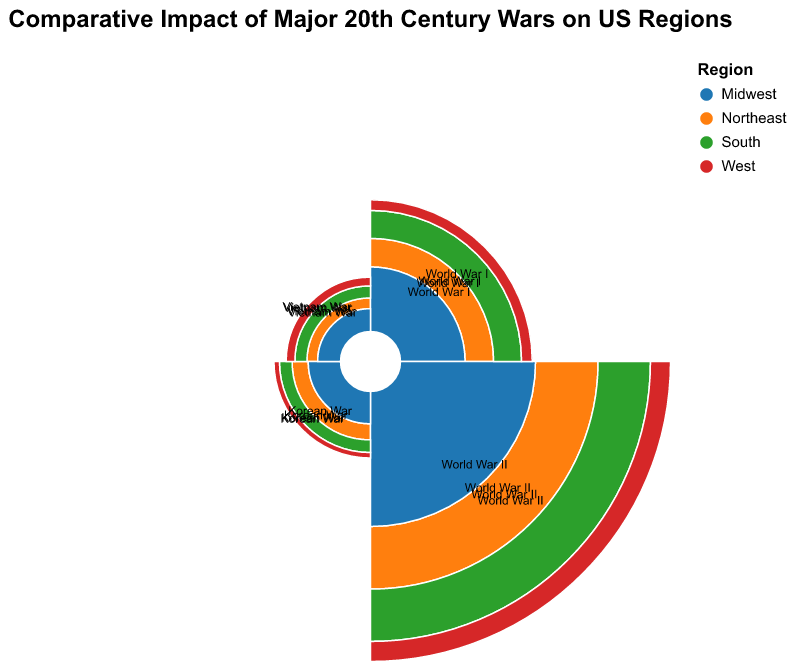what is the economic impact of World War II on the Northeast region? Look for the data point in the polar chart where the "Region" is "Northeast" and the "War" is "World War II". The tooltip information will show the economic impact which is 175,000.
Answer: 175,000 How many regions had more than 50,000 casualties in World War I? Identify the arcs relating to World War I and check the "Casualties" field. Count the regions with casualties exceeding 50,000. The Northeast and South had more than 50,000 casualties.
Answer: 2 Which region experienced the least economic impact from the Vietnam War? Check the economic impact in the text labels or tooltips for the Vietnam War arcs. The Vietnam War's economic impact is lowest in the "Northeast" region (5,000).
Answer: Northeast Is the economic impact of the Korean War higher in the Midwest or the West? Compare the economic impact data for the Korean War between the two regions. Midwest has an economic impact of 9,000, while the West has 4,500. Hence, the Midwest has a higher economic impact.
Answer: Midwest What were the total casualties in the South across all four wars? Sum the casualties for all four wars for the South region: 69,000 (WWI) + 270,000 (WWII) + 16,000 (Korean War) + 11,000 (Vietnam War). This sums up to 366,000.
Answer: 366,000 Which war caused the most casualties in the West? Identify the arc with the largest radius for the West region. World War II caused the most casualties in the West (120,000).
Answer: World War II What is the ratio of World War I to World War II casualties in the Midwest? Divide the World War I casualties by the World War II casualties for the Midwest (48,000/210,000). This ratio simplifies to approximately 0.2286.
Answer: 0.2286 What percentage of the total economic impact of World War I across all regions does the Northeast constitute? Sum the economic impact of World War I across all regions (35,000 + 32,000 + 28,000 + 15,000 = 110,000). Then, divide the Northeast's economic impact by the total (35,000/110,000), resulting in 0.318 or 31.8%.
Answer: 31.8% Between the Northeast and the West, which region's economic impact of World War II is closer to the total economic impact of the Vietnam War across all regions? Calculate the total economic impact across all regions for the Vietnam War (5,000 + 4,500 + 6,000 + 7,500 = 23,000). Then, find the absolute difference for Northeast (175,000 - 23,000 = 152,000) and West (75,000 - 23,000 = 52,000). The West's economic impact for WWII is closer to the total impact of the Vietnam War.
Answer: West 